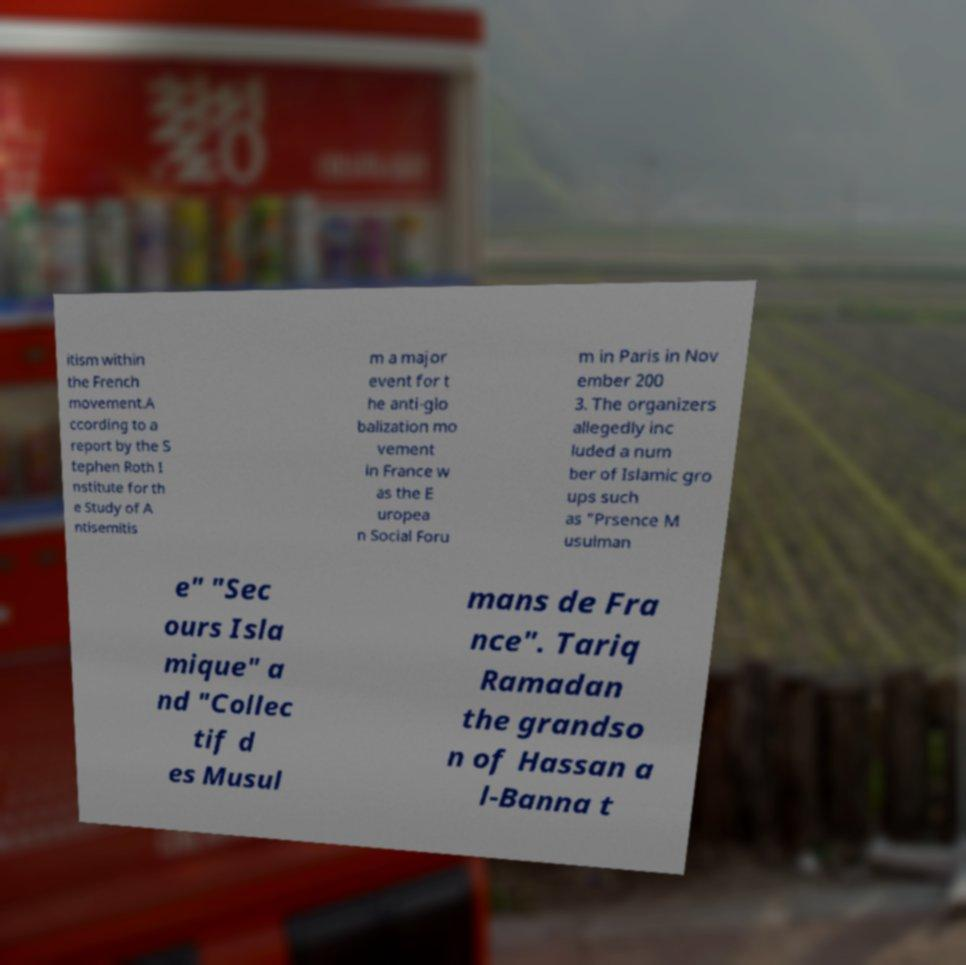For documentation purposes, I need the text within this image transcribed. Could you provide that? itism within the French movement.A ccording to a report by the S tephen Roth I nstitute for th e Study of A ntisemitis m a major event for t he anti-glo balization mo vement in France w as the E uropea n Social Foru m in Paris in Nov ember 200 3. The organizers allegedly inc luded a num ber of Islamic gro ups such as "Prsence M usulman e" "Sec ours Isla mique" a nd "Collec tif d es Musul mans de Fra nce". Tariq Ramadan the grandso n of Hassan a l-Banna t 